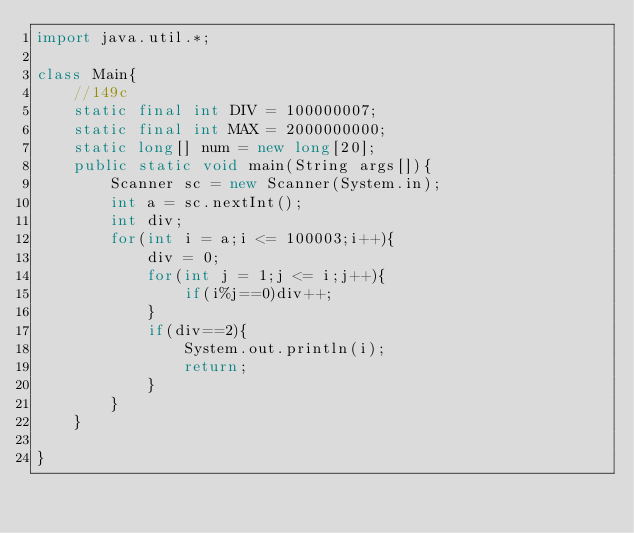Convert code to text. <code><loc_0><loc_0><loc_500><loc_500><_Java_>import java.util.*;

class Main{
    //149c
    static final int DIV = 100000007;
    static final int MAX = 2000000000;
    static long[] num = new long[20];
    public static void main(String args[]){
        Scanner sc = new Scanner(System.in);
        int a = sc.nextInt();
        int div;
        for(int i = a;i <= 100003;i++){
            div = 0;
            for(int j = 1;j <= i;j++){
                if(i%j==0)div++;
            }
            if(div==2){
                System.out.println(i);
                return;
            }
        }
    }
    
}</code> 